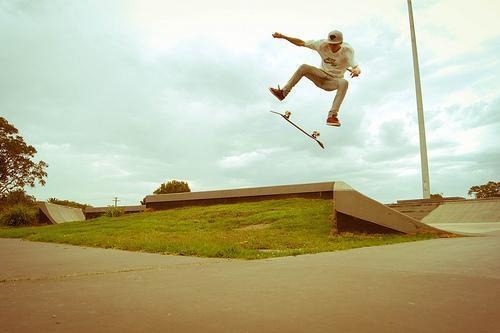How many people are in the picture?
Give a very brief answer. 1. How many wheels does the skateboard have?
Give a very brief answer. 4. 